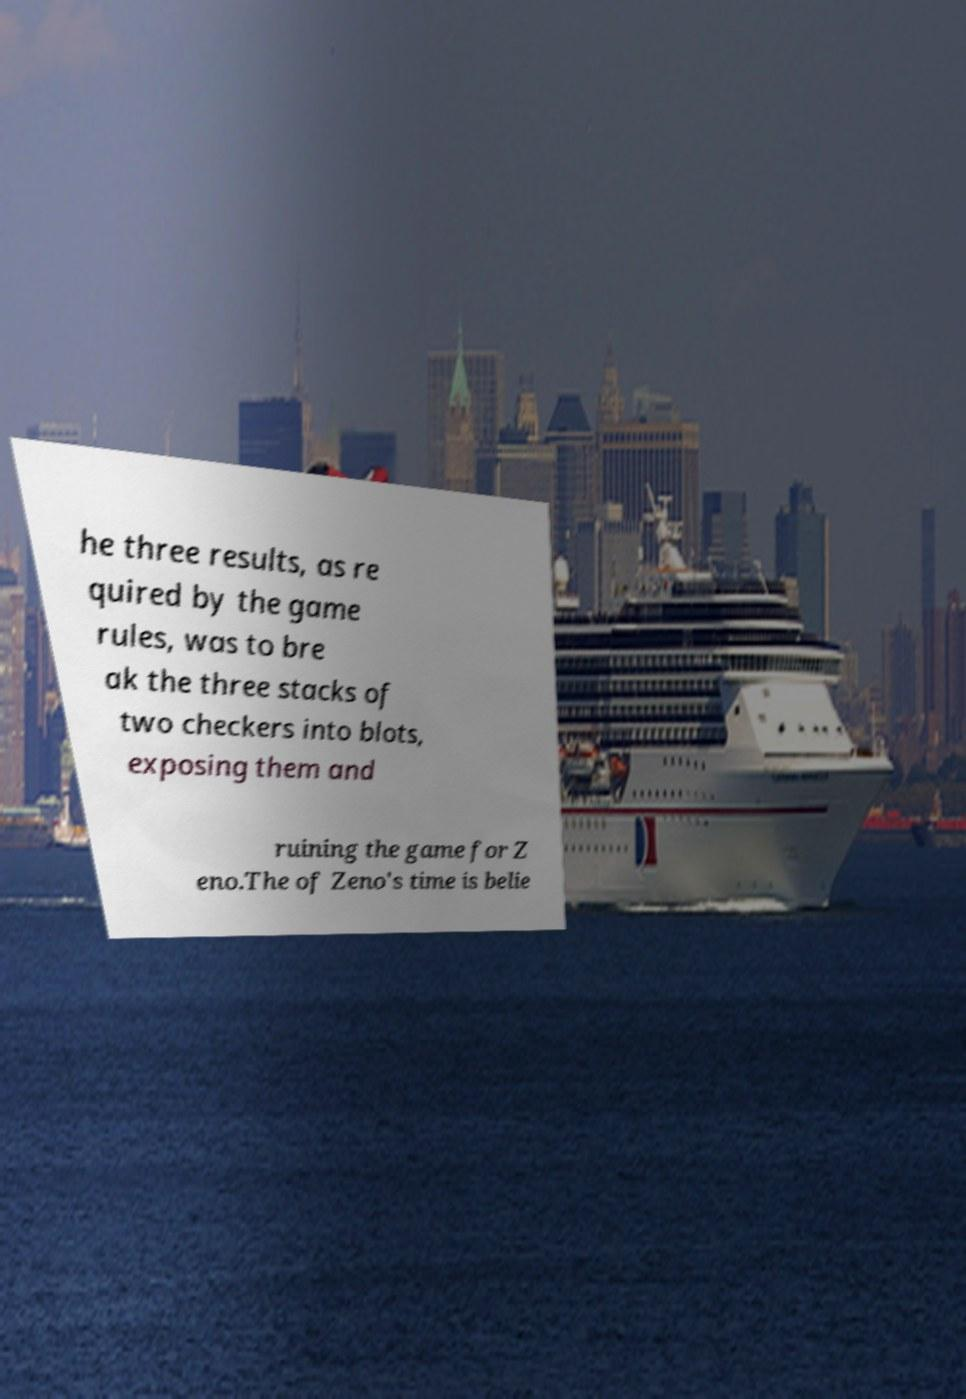Can you read and provide the text displayed in the image?This photo seems to have some interesting text. Can you extract and type it out for me? he three results, as re quired by the game rules, was to bre ak the three stacks of two checkers into blots, exposing them and ruining the game for Z eno.The of Zeno's time is belie 